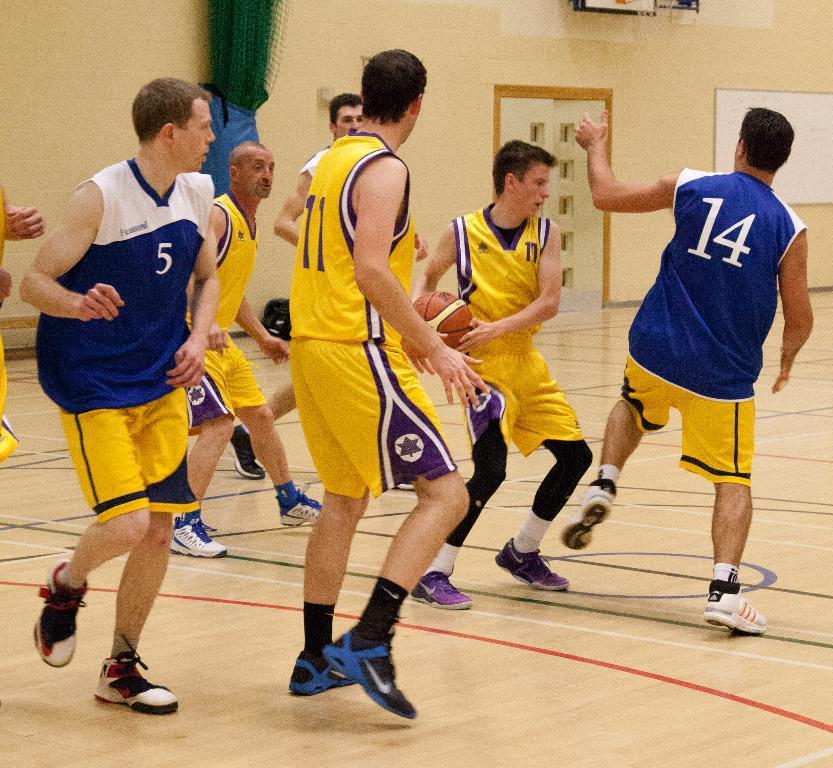Please provide a concise description of this image. In this image we can see people wearing the same costume and we can also see a ball and a white board. 